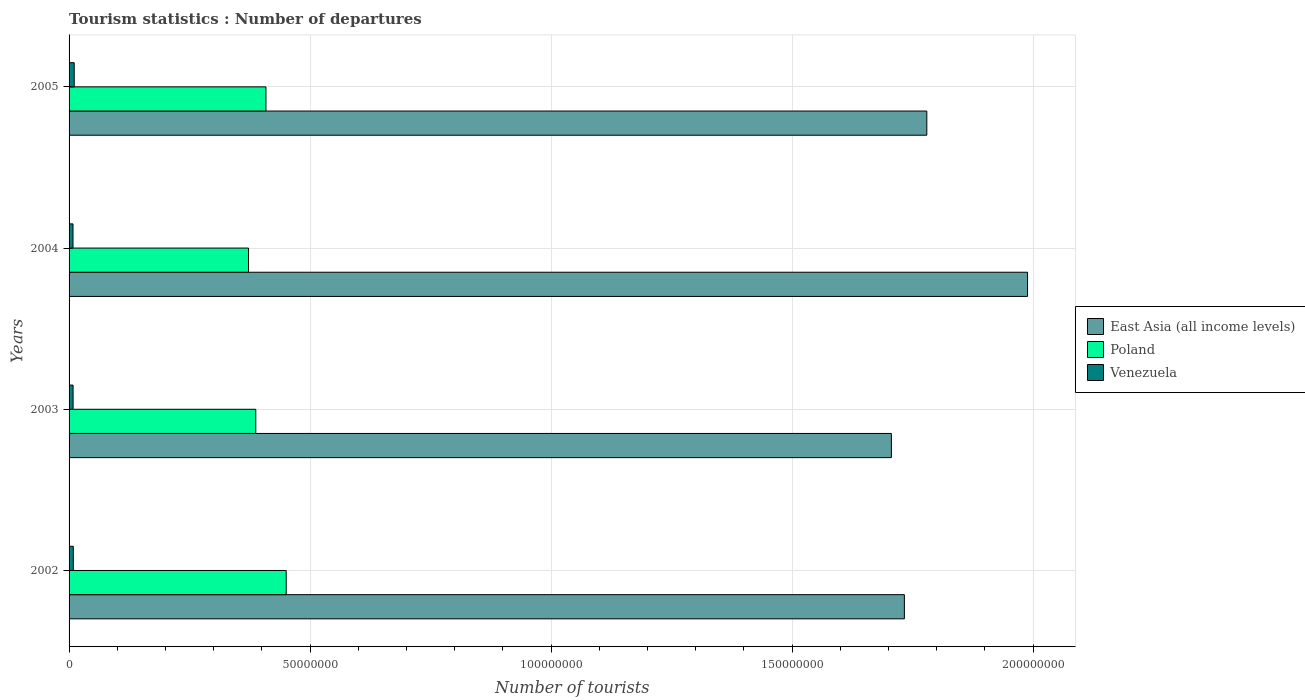How many groups of bars are there?
Your answer should be very brief. 4. Are the number of bars on each tick of the Y-axis equal?
Make the answer very short. Yes. What is the label of the 2nd group of bars from the top?
Provide a short and direct response. 2004. In how many cases, is the number of bars for a given year not equal to the number of legend labels?
Provide a succinct answer. 0. What is the number of tourist departures in Venezuela in 2003?
Your answer should be compact. 8.32e+05. Across all years, what is the maximum number of tourist departures in East Asia (all income levels)?
Keep it short and to the point. 1.99e+08. Across all years, what is the minimum number of tourist departures in Venezuela?
Provide a short and direct response. 8.16e+05. In which year was the number of tourist departures in Venezuela maximum?
Give a very brief answer. 2005. In which year was the number of tourist departures in East Asia (all income levels) minimum?
Your answer should be very brief. 2003. What is the total number of tourist departures in Poland in the graph?
Provide a succinct answer. 1.62e+08. What is the difference between the number of tourist departures in Poland in 2002 and that in 2004?
Your answer should be compact. 7.82e+06. What is the difference between the number of tourist departures in Venezuela in 2003 and the number of tourist departures in Poland in 2002?
Give a very brief answer. -4.42e+07. What is the average number of tourist departures in Poland per year?
Give a very brief answer. 4.05e+07. In the year 2002, what is the difference between the number of tourist departures in East Asia (all income levels) and number of tourist departures in Poland?
Your answer should be compact. 1.28e+08. What is the ratio of the number of tourist departures in Poland in 2004 to that in 2005?
Ensure brevity in your answer.  0.91. Is the number of tourist departures in Venezuela in 2004 less than that in 2005?
Provide a succinct answer. Yes. What is the difference between the highest and the second highest number of tourist departures in Venezuela?
Your answer should be compact. 1.86e+05. What is the difference between the highest and the lowest number of tourist departures in East Asia (all income levels)?
Your answer should be very brief. 2.82e+07. In how many years, is the number of tourist departures in Poland greater than the average number of tourist departures in Poland taken over all years?
Offer a very short reply. 2. What does the 3rd bar from the top in 2003 represents?
Make the answer very short. East Asia (all income levels). What does the 2nd bar from the bottom in 2005 represents?
Offer a very short reply. Poland. How many bars are there?
Keep it short and to the point. 12. What is the difference between two consecutive major ticks on the X-axis?
Provide a succinct answer. 5.00e+07. Are the values on the major ticks of X-axis written in scientific E-notation?
Your answer should be compact. No. Does the graph contain grids?
Keep it short and to the point. Yes. Where does the legend appear in the graph?
Offer a terse response. Center right. How many legend labels are there?
Your answer should be compact. 3. What is the title of the graph?
Provide a short and direct response. Tourism statistics : Number of departures. What is the label or title of the X-axis?
Offer a terse response. Number of tourists. What is the Number of tourists in East Asia (all income levels) in 2002?
Give a very brief answer. 1.73e+08. What is the Number of tourists in Poland in 2002?
Keep it short and to the point. 4.50e+07. What is the Number of tourists in Venezuela in 2002?
Ensure brevity in your answer.  8.81e+05. What is the Number of tourists in East Asia (all income levels) in 2003?
Provide a succinct answer. 1.71e+08. What is the Number of tourists of Poland in 2003?
Your answer should be very brief. 3.87e+07. What is the Number of tourists in Venezuela in 2003?
Make the answer very short. 8.32e+05. What is the Number of tourists of East Asia (all income levels) in 2004?
Provide a short and direct response. 1.99e+08. What is the Number of tourists in Poland in 2004?
Make the answer very short. 3.72e+07. What is the Number of tourists in Venezuela in 2004?
Keep it short and to the point. 8.16e+05. What is the Number of tourists of East Asia (all income levels) in 2005?
Provide a succinct answer. 1.78e+08. What is the Number of tourists of Poland in 2005?
Offer a terse response. 4.08e+07. What is the Number of tourists in Venezuela in 2005?
Your answer should be compact. 1.07e+06. Across all years, what is the maximum Number of tourists in East Asia (all income levels)?
Your response must be concise. 1.99e+08. Across all years, what is the maximum Number of tourists of Poland?
Your response must be concise. 4.50e+07. Across all years, what is the maximum Number of tourists of Venezuela?
Make the answer very short. 1.07e+06. Across all years, what is the minimum Number of tourists in East Asia (all income levels)?
Provide a succinct answer. 1.71e+08. Across all years, what is the minimum Number of tourists of Poland?
Your answer should be very brief. 3.72e+07. Across all years, what is the minimum Number of tourists in Venezuela?
Give a very brief answer. 8.16e+05. What is the total Number of tourists of East Asia (all income levels) in the graph?
Offer a terse response. 7.21e+08. What is the total Number of tourists in Poland in the graph?
Your answer should be compact. 1.62e+08. What is the total Number of tourists in Venezuela in the graph?
Offer a terse response. 3.60e+06. What is the difference between the Number of tourists of East Asia (all income levels) in 2002 and that in 2003?
Your response must be concise. 2.70e+06. What is the difference between the Number of tourists of Poland in 2002 and that in 2003?
Offer a very short reply. 6.31e+06. What is the difference between the Number of tourists of Venezuela in 2002 and that in 2003?
Your response must be concise. 4.90e+04. What is the difference between the Number of tourists in East Asia (all income levels) in 2002 and that in 2004?
Give a very brief answer. -2.56e+07. What is the difference between the Number of tourists in Poland in 2002 and that in 2004?
Provide a short and direct response. 7.82e+06. What is the difference between the Number of tourists in Venezuela in 2002 and that in 2004?
Offer a very short reply. 6.50e+04. What is the difference between the Number of tourists in East Asia (all income levels) in 2002 and that in 2005?
Make the answer very short. -4.65e+06. What is the difference between the Number of tourists of Poland in 2002 and that in 2005?
Provide a short and direct response. 4.20e+06. What is the difference between the Number of tourists in Venezuela in 2002 and that in 2005?
Ensure brevity in your answer.  -1.86e+05. What is the difference between the Number of tourists in East Asia (all income levels) in 2003 and that in 2004?
Keep it short and to the point. -2.82e+07. What is the difference between the Number of tourists of Poland in 2003 and that in 2004?
Ensure brevity in your answer.  1.50e+06. What is the difference between the Number of tourists of Venezuela in 2003 and that in 2004?
Your answer should be compact. 1.60e+04. What is the difference between the Number of tourists of East Asia (all income levels) in 2003 and that in 2005?
Ensure brevity in your answer.  -7.35e+06. What is the difference between the Number of tourists of Poland in 2003 and that in 2005?
Provide a succinct answer. -2.11e+06. What is the difference between the Number of tourists in Venezuela in 2003 and that in 2005?
Provide a short and direct response. -2.35e+05. What is the difference between the Number of tourists in East Asia (all income levels) in 2004 and that in 2005?
Offer a very short reply. 2.09e+07. What is the difference between the Number of tourists in Poland in 2004 and that in 2005?
Make the answer very short. -3.62e+06. What is the difference between the Number of tourists in Venezuela in 2004 and that in 2005?
Make the answer very short. -2.51e+05. What is the difference between the Number of tourists in East Asia (all income levels) in 2002 and the Number of tourists in Poland in 2003?
Ensure brevity in your answer.  1.35e+08. What is the difference between the Number of tourists of East Asia (all income levels) in 2002 and the Number of tourists of Venezuela in 2003?
Make the answer very short. 1.72e+08. What is the difference between the Number of tourists in Poland in 2002 and the Number of tourists in Venezuela in 2003?
Your answer should be compact. 4.42e+07. What is the difference between the Number of tourists in East Asia (all income levels) in 2002 and the Number of tourists in Poland in 2004?
Your answer should be very brief. 1.36e+08. What is the difference between the Number of tourists in East Asia (all income levels) in 2002 and the Number of tourists in Venezuela in 2004?
Offer a terse response. 1.72e+08. What is the difference between the Number of tourists in Poland in 2002 and the Number of tourists in Venezuela in 2004?
Offer a very short reply. 4.42e+07. What is the difference between the Number of tourists of East Asia (all income levels) in 2002 and the Number of tourists of Poland in 2005?
Keep it short and to the point. 1.32e+08. What is the difference between the Number of tourists in East Asia (all income levels) in 2002 and the Number of tourists in Venezuela in 2005?
Your answer should be very brief. 1.72e+08. What is the difference between the Number of tourists in Poland in 2002 and the Number of tourists in Venezuela in 2005?
Make the answer very short. 4.40e+07. What is the difference between the Number of tourists of East Asia (all income levels) in 2003 and the Number of tourists of Poland in 2004?
Give a very brief answer. 1.33e+08. What is the difference between the Number of tourists of East Asia (all income levels) in 2003 and the Number of tourists of Venezuela in 2004?
Your answer should be compact. 1.70e+08. What is the difference between the Number of tourists of Poland in 2003 and the Number of tourists of Venezuela in 2004?
Give a very brief answer. 3.79e+07. What is the difference between the Number of tourists in East Asia (all income levels) in 2003 and the Number of tourists in Poland in 2005?
Your answer should be compact. 1.30e+08. What is the difference between the Number of tourists in East Asia (all income levels) in 2003 and the Number of tourists in Venezuela in 2005?
Keep it short and to the point. 1.70e+08. What is the difference between the Number of tourists in Poland in 2003 and the Number of tourists in Venezuela in 2005?
Your response must be concise. 3.77e+07. What is the difference between the Number of tourists in East Asia (all income levels) in 2004 and the Number of tourists in Poland in 2005?
Provide a succinct answer. 1.58e+08. What is the difference between the Number of tourists in East Asia (all income levels) in 2004 and the Number of tourists in Venezuela in 2005?
Your answer should be very brief. 1.98e+08. What is the difference between the Number of tourists of Poland in 2004 and the Number of tourists of Venezuela in 2005?
Your answer should be compact. 3.62e+07. What is the average Number of tourists of East Asia (all income levels) per year?
Your answer should be very brief. 1.80e+08. What is the average Number of tourists of Poland per year?
Offer a very short reply. 4.05e+07. What is the average Number of tourists in Venezuela per year?
Offer a very short reply. 8.99e+05. In the year 2002, what is the difference between the Number of tourists of East Asia (all income levels) and Number of tourists of Poland?
Provide a short and direct response. 1.28e+08. In the year 2002, what is the difference between the Number of tourists of East Asia (all income levels) and Number of tourists of Venezuela?
Offer a very short reply. 1.72e+08. In the year 2002, what is the difference between the Number of tourists in Poland and Number of tourists in Venezuela?
Ensure brevity in your answer.  4.42e+07. In the year 2003, what is the difference between the Number of tourists in East Asia (all income levels) and Number of tourists in Poland?
Give a very brief answer. 1.32e+08. In the year 2003, what is the difference between the Number of tourists of East Asia (all income levels) and Number of tourists of Venezuela?
Provide a succinct answer. 1.70e+08. In the year 2003, what is the difference between the Number of tourists in Poland and Number of tourists in Venezuela?
Offer a very short reply. 3.79e+07. In the year 2004, what is the difference between the Number of tourists in East Asia (all income levels) and Number of tourists in Poland?
Offer a terse response. 1.62e+08. In the year 2004, what is the difference between the Number of tourists in East Asia (all income levels) and Number of tourists in Venezuela?
Your response must be concise. 1.98e+08. In the year 2004, what is the difference between the Number of tourists of Poland and Number of tourists of Venezuela?
Ensure brevity in your answer.  3.64e+07. In the year 2005, what is the difference between the Number of tourists of East Asia (all income levels) and Number of tourists of Poland?
Offer a very short reply. 1.37e+08. In the year 2005, what is the difference between the Number of tourists of East Asia (all income levels) and Number of tourists of Venezuela?
Make the answer very short. 1.77e+08. In the year 2005, what is the difference between the Number of tourists in Poland and Number of tourists in Venezuela?
Make the answer very short. 3.98e+07. What is the ratio of the Number of tourists in East Asia (all income levels) in 2002 to that in 2003?
Your response must be concise. 1.02. What is the ratio of the Number of tourists in Poland in 2002 to that in 2003?
Provide a succinct answer. 1.16. What is the ratio of the Number of tourists in Venezuela in 2002 to that in 2003?
Ensure brevity in your answer.  1.06. What is the ratio of the Number of tourists of East Asia (all income levels) in 2002 to that in 2004?
Offer a terse response. 0.87. What is the ratio of the Number of tourists in Poland in 2002 to that in 2004?
Offer a very short reply. 1.21. What is the ratio of the Number of tourists of Venezuela in 2002 to that in 2004?
Offer a very short reply. 1.08. What is the ratio of the Number of tourists in East Asia (all income levels) in 2002 to that in 2005?
Offer a terse response. 0.97. What is the ratio of the Number of tourists in Poland in 2002 to that in 2005?
Offer a terse response. 1.1. What is the ratio of the Number of tourists in Venezuela in 2002 to that in 2005?
Ensure brevity in your answer.  0.83. What is the ratio of the Number of tourists in East Asia (all income levels) in 2003 to that in 2004?
Give a very brief answer. 0.86. What is the ratio of the Number of tourists in Poland in 2003 to that in 2004?
Your answer should be compact. 1.04. What is the ratio of the Number of tourists of Venezuela in 2003 to that in 2004?
Your answer should be compact. 1.02. What is the ratio of the Number of tourists in East Asia (all income levels) in 2003 to that in 2005?
Give a very brief answer. 0.96. What is the ratio of the Number of tourists of Poland in 2003 to that in 2005?
Your answer should be compact. 0.95. What is the ratio of the Number of tourists of Venezuela in 2003 to that in 2005?
Provide a short and direct response. 0.78. What is the ratio of the Number of tourists of East Asia (all income levels) in 2004 to that in 2005?
Ensure brevity in your answer.  1.12. What is the ratio of the Number of tourists in Poland in 2004 to that in 2005?
Ensure brevity in your answer.  0.91. What is the ratio of the Number of tourists in Venezuela in 2004 to that in 2005?
Provide a short and direct response. 0.76. What is the difference between the highest and the second highest Number of tourists of East Asia (all income levels)?
Offer a very short reply. 2.09e+07. What is the difference between the highest and the second highest Number of tourists in Poland?
Give a very brief answer. 4.20e+06. What is the difference between the highest and the second highest Number of tourists in Venezuela?
Your answer should be compact. 1.86e+05. What is the difference between the highest and the lowest Number of tourists of East Asia (all income levels)?
Your response must be concise. 2.82e+07. What is the difference between the highest and the lowest Number of tourists of Poland?
Keep it short and to the point. 7.82e+06. What is the difference between the highest and the lowest Number of tourists in Venezuela?
Offer a very short reply. 2.51e+05. 